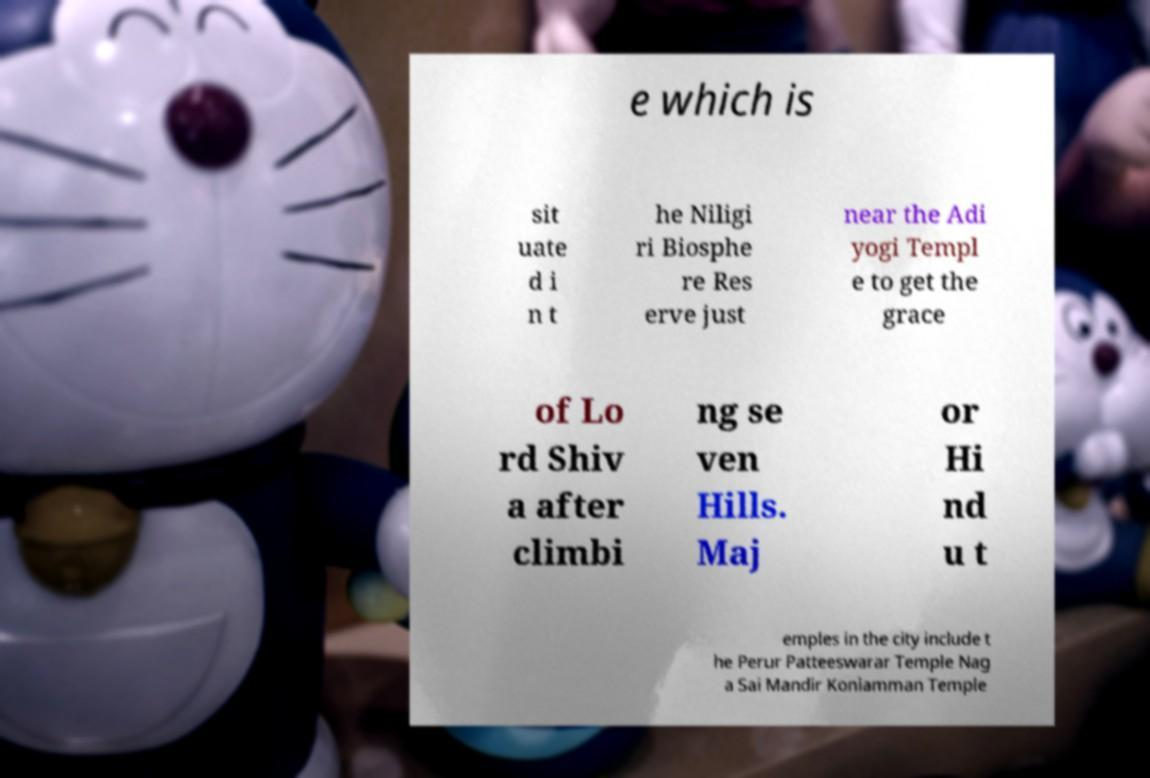Please read and relay the text visible in this image. What does it say? e which is sit uate d i n t he Niligi ri Biosphe re Res erve just near the Adi yogi Templ e to get the grace of Lo rd Shiv a after climbi ng se ven Hills. Maj or Hi nd u t emples in the city include t he Perur Patteeswarar Temple Nag a Sai Mandir Koniamman Temple 